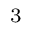<formula> <loc_0><loc_0><loc_500><loc_500>_ { 3 }</formula> 